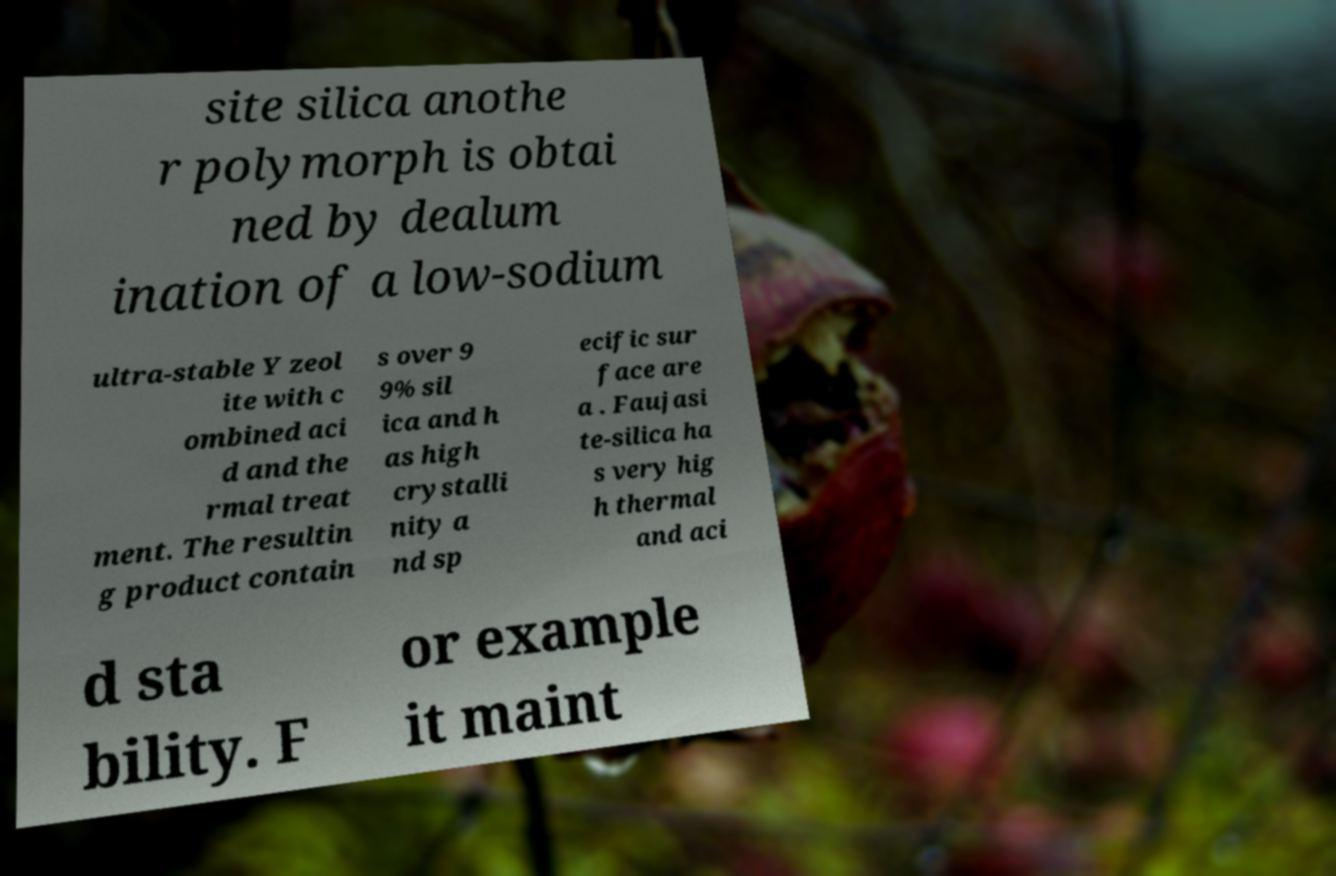Could you extract and type out the text from this image? site silica anothe r polymorph is obtai ned by dealum ination of a low-sodium ultra-stable Y zeol ite with c ombined aci d and the rmal treat ment. The resultin g product contain s over 9 9% sil ica and h as high crystalli nity a nd sp ecific sur face are a . Faujasi te-silica ha s very hig h thermal and aci d sta bility. F or example it maint 